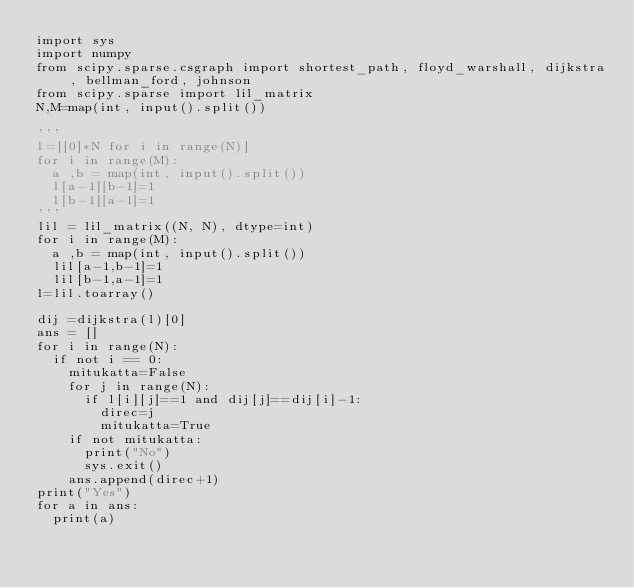Convert code to text. <code><loc_0><loc_0><loc_500><loc_500><_Python_>import sys
import numpy
from scipy.sparse.csgraph import shortest_path, floyd_warshall, dijkstra, bellman_ford, johnson
from scipy.sparse import lil_matrix
N,M=map(int, input().split())

'''
l=[[0]*N for i in range(N)]
for i in range(M):
  a ,b = map(int, input().split())
  l[a-1][b-1]=1
  l[b-1][a-1]=1
'''
lil = lil_matrix((N, N), dtype=int)
for i in range(M):
  a ,b = map(int, input().split())
  lil[a-1,b-1]=1
  lil[b-1,a-1]=1
l=lil.toarray()

dij =dijkstra(l)[0]
ans = []
for i in range(N):
  if not i == 0:
    mitukatta=False
    for j in range(N):
      if l[i][j]==1 and dij[j]==dij[i]-1:
        direc=j
        mitukatta=True
    if not mitukatta:
      print("No")
      sys.exit()
    ans.append(direc+1)
print("Yes")
for a in ans:
  print(a)</code> 